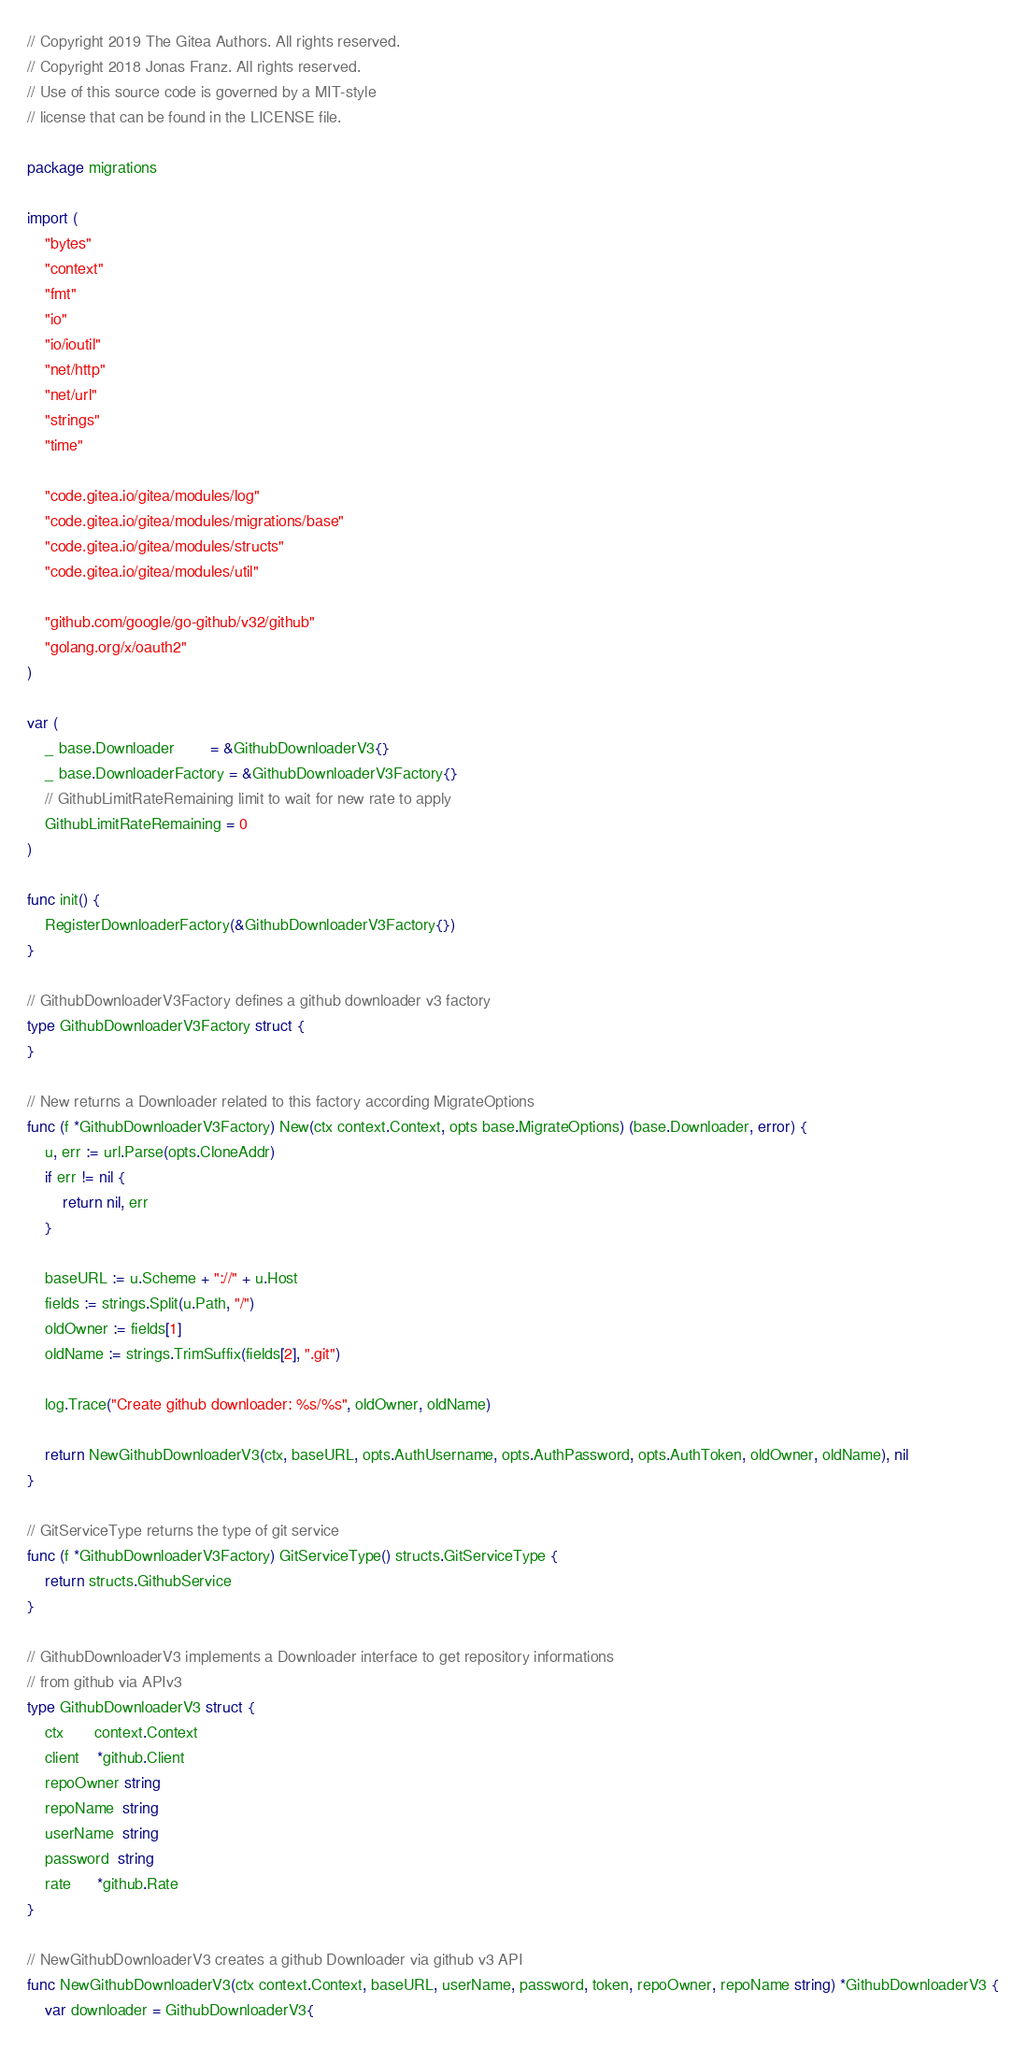Convert code to text. <code><loc_0><loc_0><loc_500><loc_500><_Go_>// Copyright 2019 The Gitea Authors. All rights reserved.
// Copyright 2018 Jonas Franz. All rights reserved.
// Use of this source code is governed by a MIT-style
// license that can be found in the LICENSE file.

package migrations

import (
	"bytes"
	"context"
	"fmt"
	"io"
	"io/ioutil"
	"net/http"
	"net/url"
	"strings"
	"time"

	"code.gitea.io/gitea/modules/log"
	"code.gitea.io/gitea/modules/migrations/base"
	"code.gitea.io/gitea/modules/structs"
	"code.gitea.io/gitea/modules/util"

	"github.com/google/go-github/v32/github"
	"golang.org/x/oauth2"
)

var (
	_ base.Downloader        = &GithubDownloaderV3{}
	_ base.DownloaderFactory = &GithubDownloaderV3Factory{}
	// GithubLimitRateRemaining limit to wait for new rate to apply
	GithubLimitRateRemaining = 0
)

func init() {
	RegisterDownloaderFactory(&GithubDownloaderV3Factory{})
}

// GithubDownloaderV3Factory defines a github downloader v3 factory
type GithubDownloaderV3Factory struct {
}

// New returns a Downloader related to this factory according MigrateOptions
func (f *GithubDownloaderV3Factory) New(ctx context.Context, opts base.MigrateOptions) (base.Downloader, error) {
	u, err := url.Parse(opts.CloneAddr)
	if err != nil {
		return nil, err
	}

	baseURL := u.Scheme + "://" + u.Host
	fields := strings.Split(u.Path, "/")
	oldOwner := fields[1]
	oldName := strings.TrimSuffix(fields[2], ".git")

	log.Trace("Create github downloader: %s/%s", oldOwner, oldName)

	return NewGithubDownloaderV3(ctx, baseURL, opts.AuthUsername, opts.AuthPassword, opts.AuthToken, oldOwner, oldName), nil
}

// GitServiceType returns the type of git service
func (f *GithubDownloaderV3Factory) GitServiceType() structs.GitServiceType {
	return structs.GithubService
}

// GithubDownloaderV3 implements a Downloader interface to get repository informations
// from github via APIv3
type GithubDownloaderV3 struct {
	ctx       context.Context
	client    *github.Client
	repoOwner string
	repoName  string
	userName  string
	password  string
	rate      *github.Rate
}

// NewGithubDownloaderV3 creates a github Downloader via github v3 API
func NewGithubDownloaderV3(ctx context.Context, baseURL, userName, password, token, repoOwner, repoName string) *GithubDownloaderV3 {
	var downloader = GithubDownloaderV3{</code> 